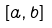<formula> <loc_0><loc_0><loc_500><loc_500>[ a , b ]</formula> 